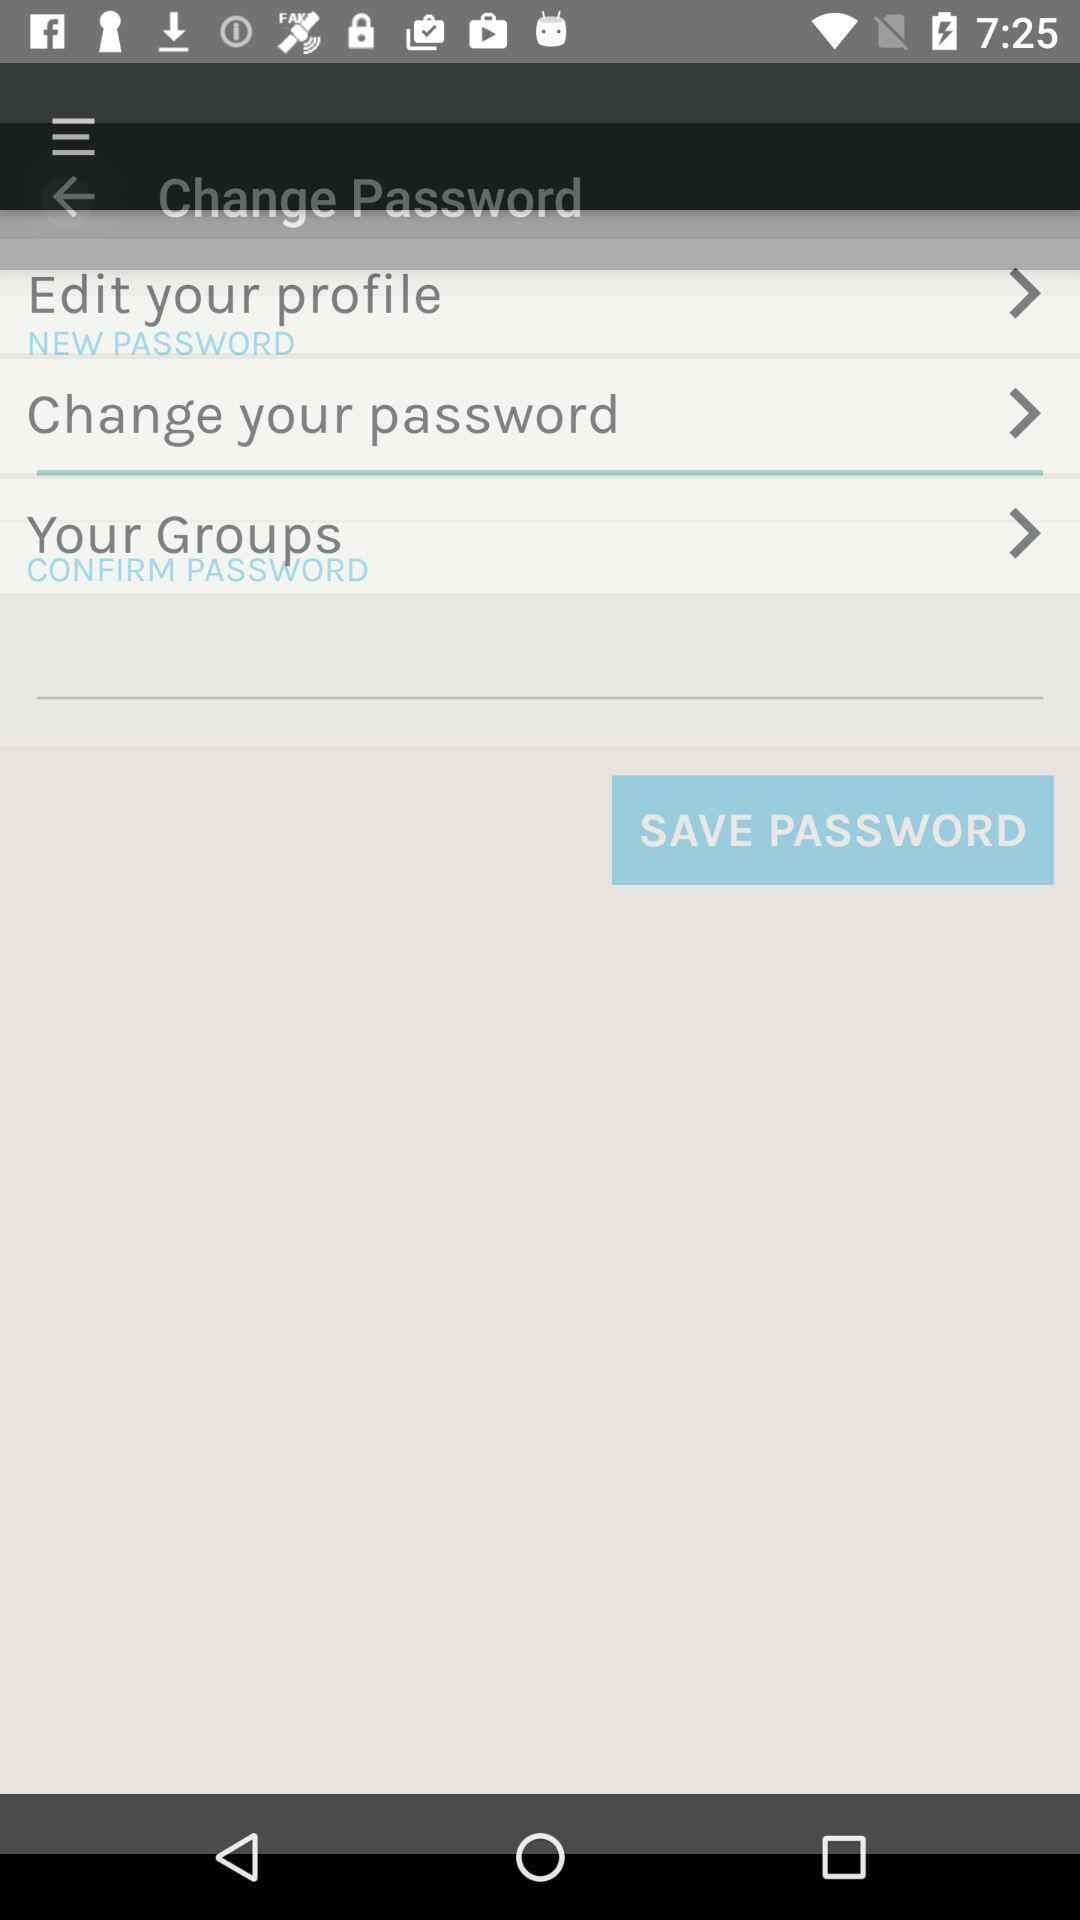Describe the content in this image. Screen showing change password. 